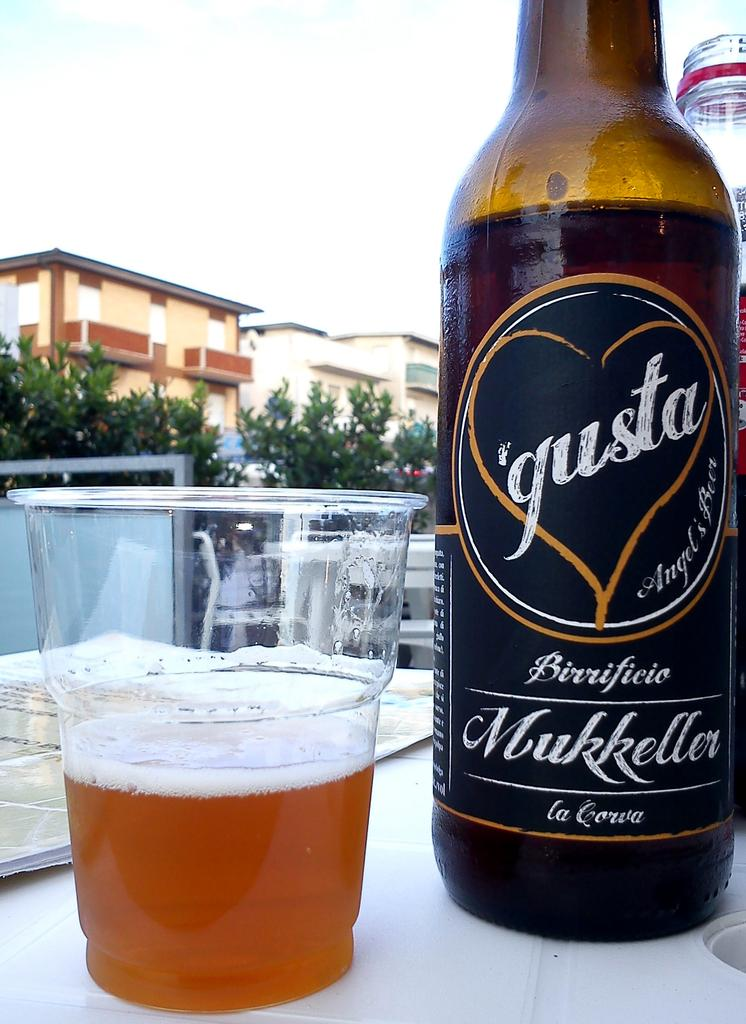<image>
Create a compact narrative representing the image presented. a glass of beer is sitting next to a bottle of beer from Gusta. 